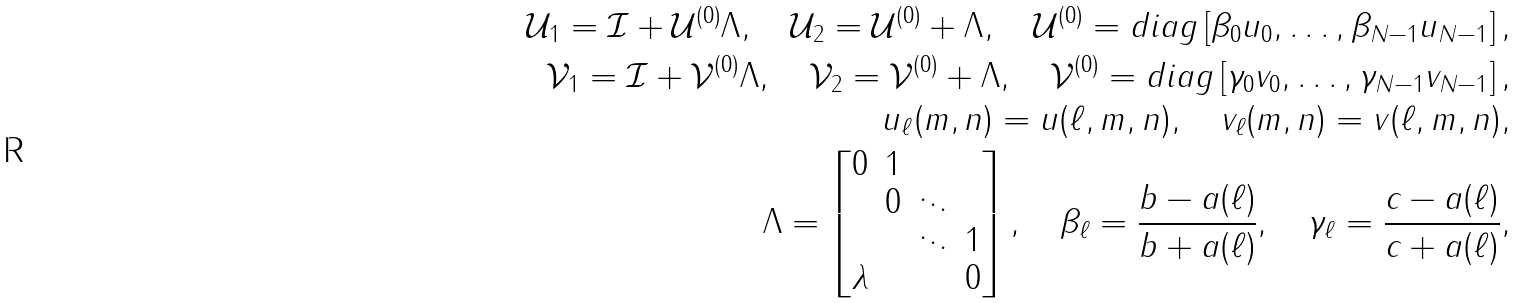<formula> <loc_0><loc_0><loc_500><loc_500>\mathcal { U } _ { 1 } = \mathcal { I } + \mathcal { U } ^ { ( 0 ) } \Lambda , \quad \mathcal { U } _ { 2 } = \mathcal { U } ^ { ( 0 ) } + \Lambda , \quad \mathcal { U } ^ { ( 0 ) } = d i a g \left [ \beta _ { 0 } u _ { 0 } , \dots , \beta _ { N - 1 } u _ { N - 1 } \right ] , \\ \mathcal { V } _ { 1 } = \mathcal { I } + \mathcal { V } ^ { ( 0 ) } \Lambda , \quad \mathcal { V } _ { 2 } = \mathcal { V } ^ { ( 0 ) } + \Lambda , \quad \mathcal { V } ^ { ( 0 ) } = d i a g \left [ \gamma _ { 0 } v _ { 0 } , \dots , \gamma _ { N - 1 } v _ { N - 1 } \right ] , \\ u _ { \ell } ( m , n ) = u ( \ell , m , n ) , \quad v _ { \ell } ( m , n ) = v ( \ell , m , n ) , \\ \Lambda = \begin{bmatrix} 0 & 1 & & \\ & 0 & \ddots & \\ & & \ddots & 1 \\ \lambda & & & 0 \end{bmatrix} , \quad \beta _ { \ell } = \frac { b - a ( \ell ) } { b + a ( \ell ) } , \quad \gamma _ { \ell } = \frac { c - a ( \ell ) } { c + a ( \ell ) } ,</formula> 